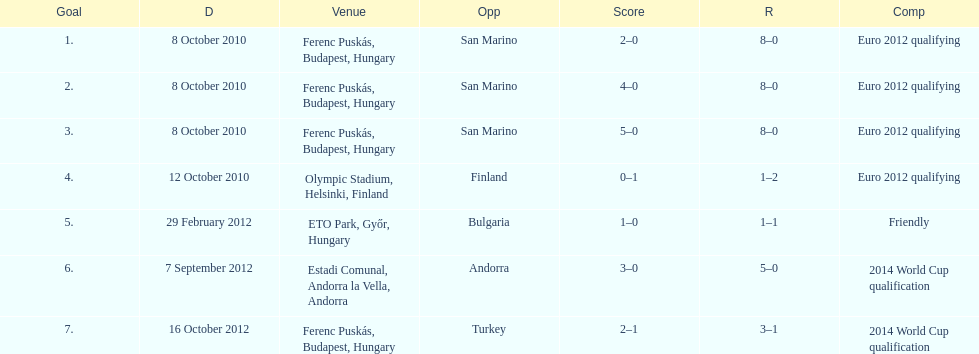How many non-qualifying games did he score in? 1. 